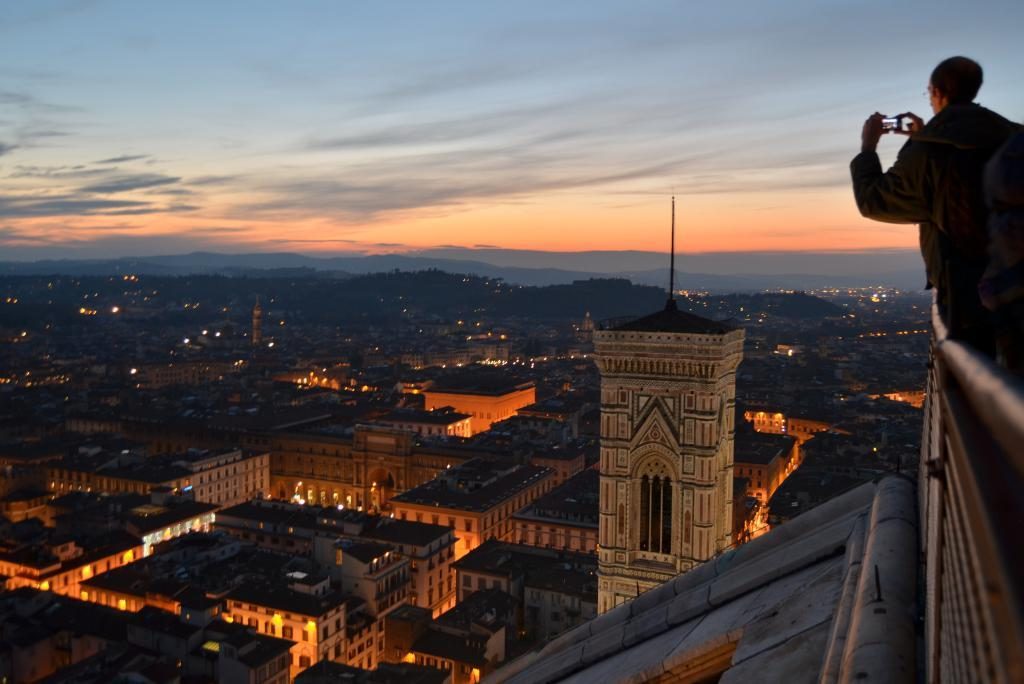What is the person in the image doing on the terrace? The person is standing on the terrace. What object is the person holding in the image? The person is holding a phone. What can be seen in the background of the image? Multiple buildings are visible in the image. Is the person's brother present at the meeting in the image? There is no mention of a brother or a meeting in the image, so it cannot be determined if the person's brother is present. 